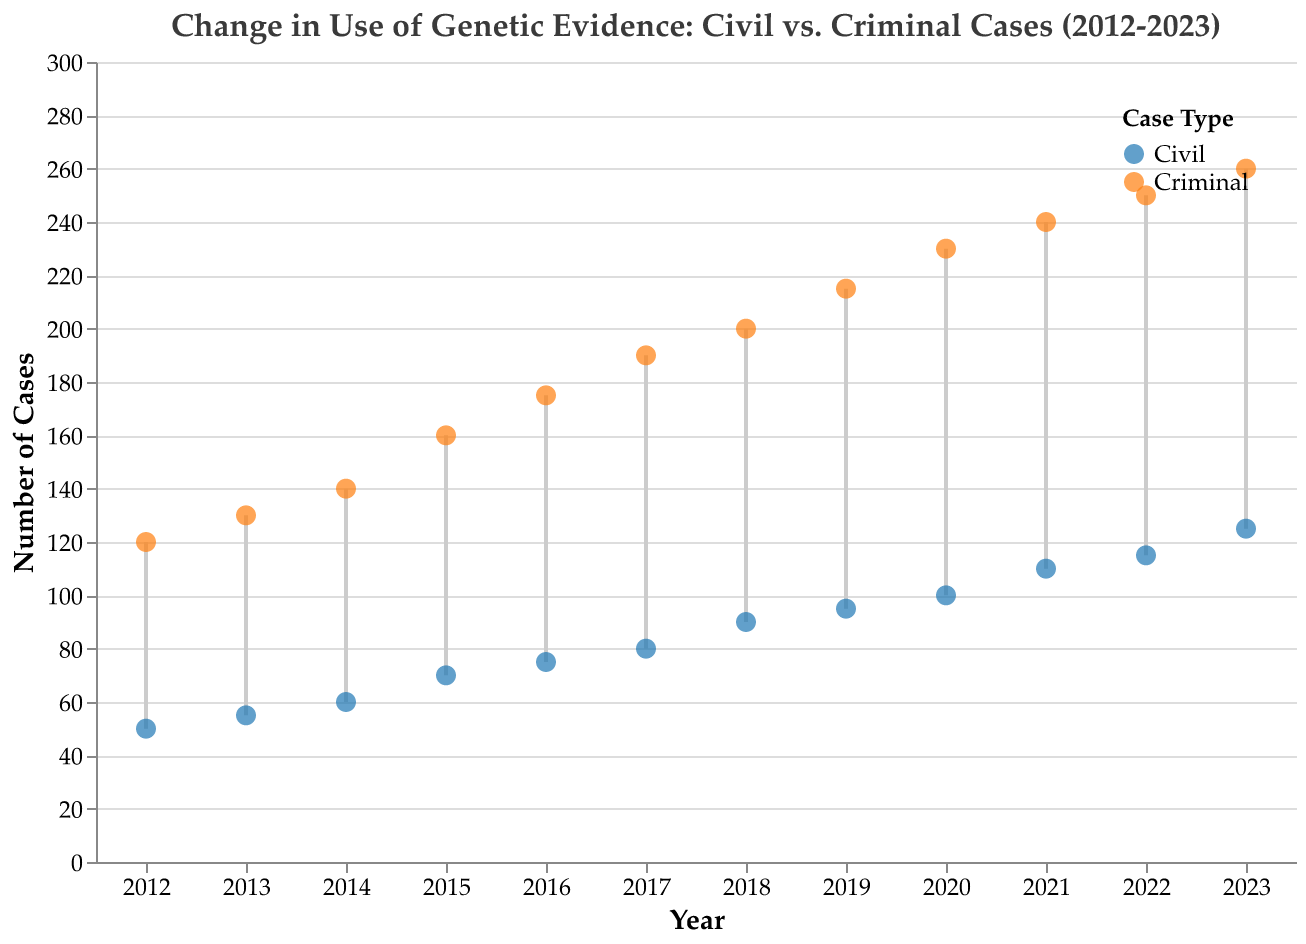what is the title of the figure? The title is prominent at the top of the figure. It provides an overview of the data displayed. The title reads "Change in Use of Genetic Evidence: Civil vs. Criminal Cases (2012-2023)".
Answer: Change in Use of Genetic Evidence: Civil vs. Criminal Cases (2012-2023) How many years are displayed in the plot? The x-axis represents the years, and by counting the number of distinct ticks, we can identify the years. The years range from 2012 to 2023, inclusive.
Answer: 12 years Which case type saw the highest use of genetic evidence in 2023? Looking at the points for the year 2023, the plot's legend helps distinguish between civil (blue) and criminal (orange) cases. The point for criminal cases in 2023 is the highest.
Answer: Criminal cases How much did the use of genetic evidence in civil cases increase from 2012 to 2023? The number of cases using genetic evidence in civil cases in 2012 was 50 and increased to 125 in 2023. The increase is calculated by subtracting 50 from 125.
Answer: 75 cases In which year did criminal cases first utilize genetic evidence more than 150 times? By tracing the orange points for criminal cases and observing the y-axis values, we notice that in 2015, the number of cases exceeded 150 for the first time.
Answer: 2015 What is the median number of cases utilizing genetic evidence across all years for criminal cases? To find the median, we list the number of cases yearly: 120, 130, 140, 160, 175, 190, 200, 215, 230, 240, 250, 260. With 12 values, the median is the average of the 6th and 7th values: (190 + 200) / 2.
Answer: 195 Compare the number of cases using genetic evidence in civil and criminal cases in 2017. In 2017, the number for civil cases was 80 and for criminal cases was 190. Comparing these, criminal cases had more.
Answer: Criminal cases had 110 more cases What is the overall trend in the use of genetic evidence in civil cases from 2012 to 2023? Observing the blue points for civil cases, there is a consistent upward trend from 2012 (50 cases) to 2023 (125 cases). This indicates an increase over the period.
Answer: Upward trend What year had the closest number of genetic evidence cases between civil and criminal types? Comparing year by year, 2012 has the smallest difference between civil (50) and criminal (120) cases, with a difference of 70, which is smaller compared to other years.
Answer: 2012 How has the gap between civil and criminal cases usage of genetic evidence evolved from 2012 to 2023? Initially, in 2012, the gap was 70 cases (120 criminal - 50 civil). By 2023, this gap increased to 135 cases (260 criminal - 125 civil), showing that the gap has widened over the years.
Answer: Widened What was the average number of cases using genetic evidence in criminal cases over the entire period? Sum the number of cases in each year for criminal cases: 120+130+140+160+175+190+200+215+230+240+250+260 = 2310. Divide this by the number of years, 12, to get the average.
Answer: 192.5 